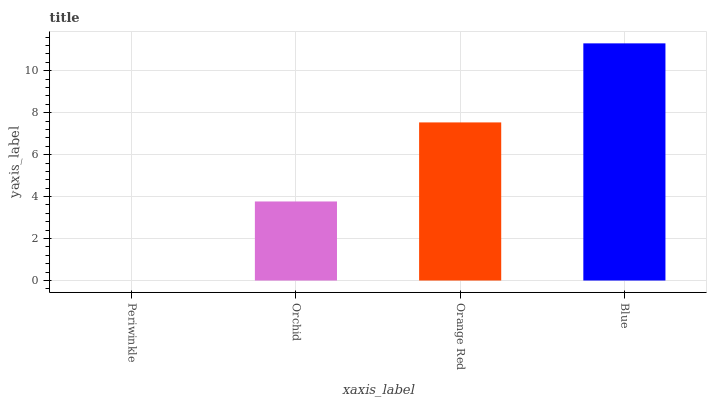Is Periwinkle the minimum?
Answer yes or no. Yes. Is Blue the maximum?
Answer yes or no. Yes. Is Orchid the minimum?
Answer yes or no. No. Is Orchid the maximum?
Answer yes or no. No. Is Orchid greater than Periwinkle?
Answer yes or no. Yes. Is Periwinkle less than Orchid?
Answer yes or no. Yes. Is Periwinkle greater than Orchid?
Answer yes or no. No. Is Orchid less than Periwinkle?
Answer yes or no. No. Is Orange Red the high median?
Answer yes or no. Yes. Is Orchid the low median?
Answer yes or no. Yes. Is Blue the high median?
Answer yes or no. No. Is Periwinkle the low median?
Answer yes or no. No. 